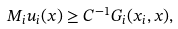Convert formula to latex. <formula><loc_0><loc_0><loc_500><loc_500>M _ { i } u _ { i } ( x ) \geq C ^ { - 1 } G _ { i } ( x _ { i } , x ) ,</formula> 